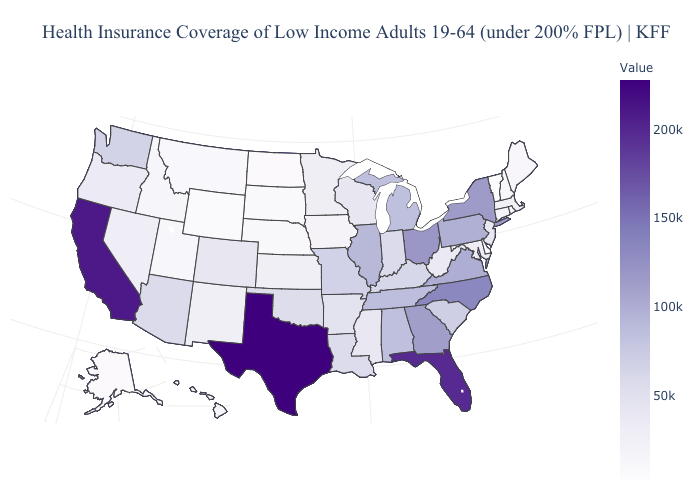Among the states that border Minnesota , does Iowa have the highest value?
Concise answer only. No. Does Illinois have the lowest value in the USA?
Short answer required. No. Is the legend a continuous bar?
Keep it brief. Yes. Does the map have missing data?
Keep it brief. No. Does North Dakota have the lowest value in the MidWest?
Quick response, please. Yes. Is the legend a continuous bar?
Concise answer only. Yes. 